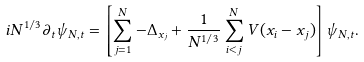Convert formula to latex. <formula><loc_0><loc_0><loc_500><loc_500>i N ^ { 1 / 3 } \partial _ { t } \psi _ { N , t } = \left [ \sum _ { j = 1 } ^ { N } - \Delta _ { x _ { j } } + \frac { 1 } { N ^ { 1 / 3 } } \sum _ { i < j } ^ { N } V ( x _ { i } - x _ { j } ) \right ] \psi _ { N , t } .</formula> 